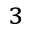Convert formula to latex. <formula><loc_0><loc_0><loc_500><loc_500>^ { 3 }</formula> 